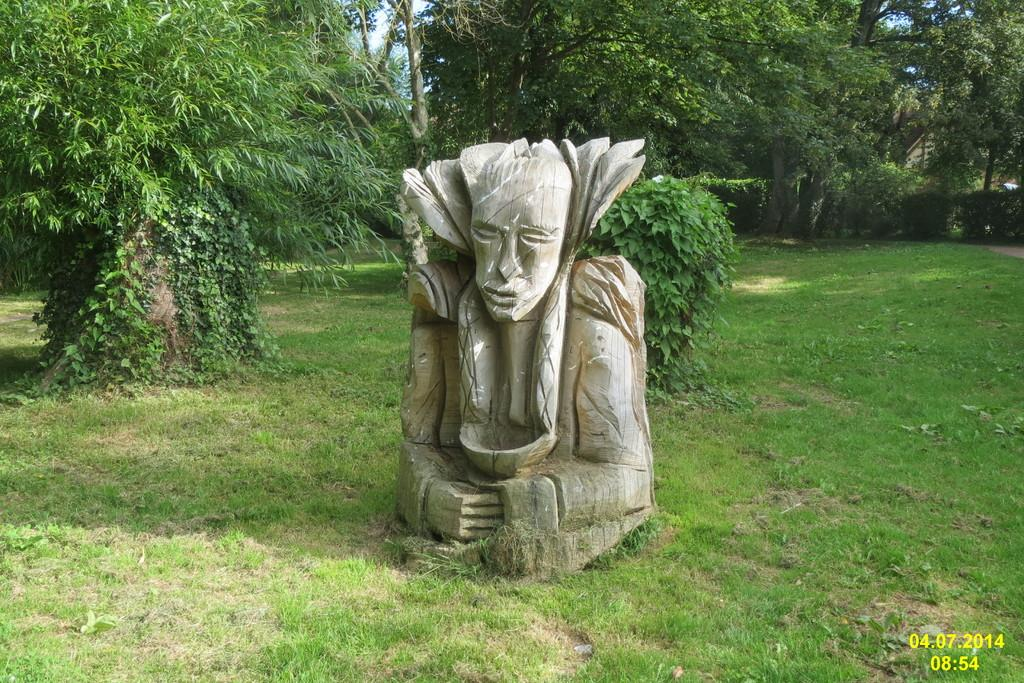What is the main subject of the image? There is a sculpture in the image. What can be seen behind the sculpture? There are trees behind the sculpture. What type of vegetation is visible in the image? There is grass visible in the image. What part of the natural environment is visible in the image? The sky is visible in the image. What type of pin can be seen holding the sculpture together in the image? There is no pin visible in the image holding the sculpture together. What kind of apparatus is used to stretch the trees in the image? There is no apparatus visible in the image for stretching the trees. 